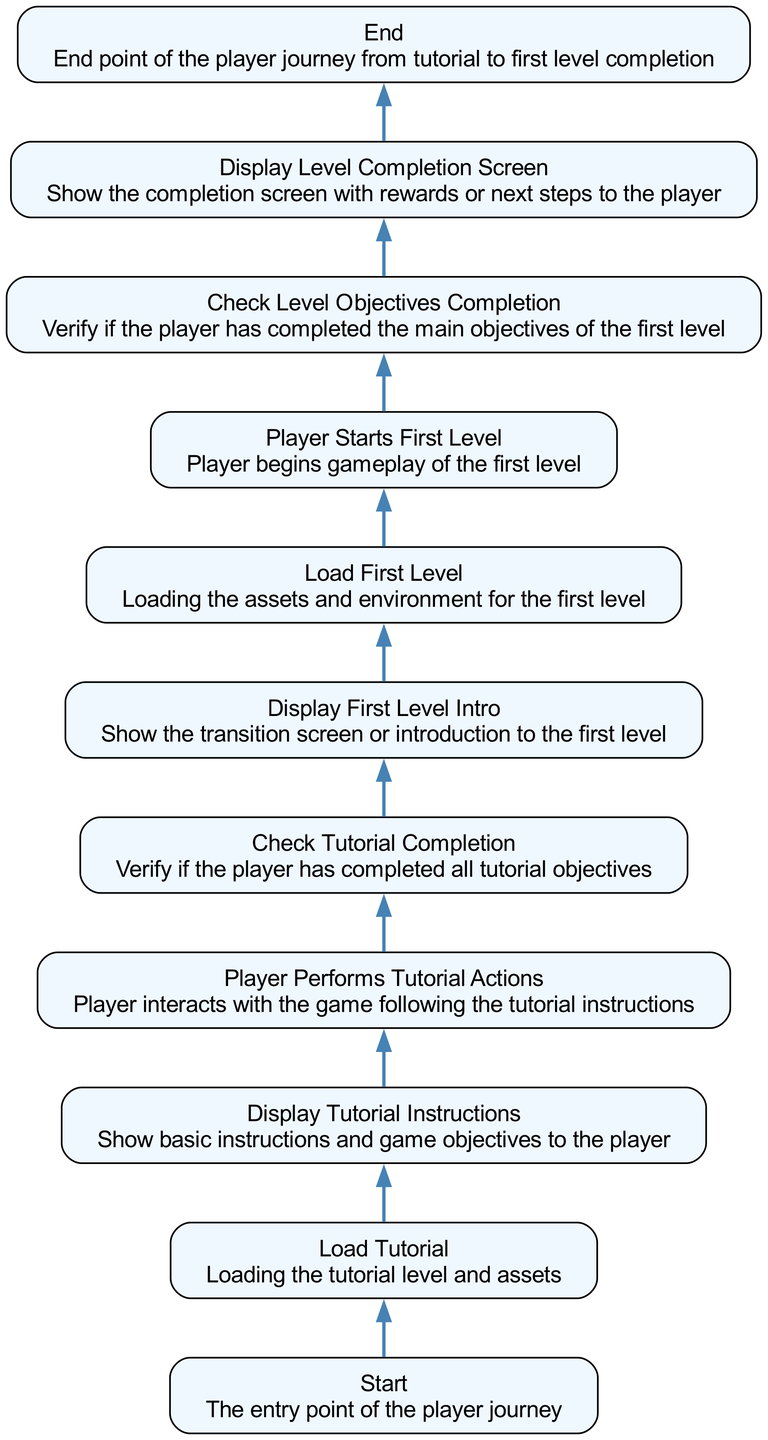What is the first node in the diagram? The first node listed in the flow chart is labeled "Start," marking the entry point where the player journey begins.
Answer: Start How many nodes are present in the diagram? By counting the nodes listed, there are a total of eleven distinct nodes representing various steps in the player journey from tutorial to first level completion.
Answer: Eleven What follows the "Check Tutorial Completion" node? Directly succeeding the "Check Tutorial Completion" node, the next step is the "Display First Level Intro," indicating what comes after checking tutorial progress.
Answer: Display First Level Intro Which node represents the player's initial interaction with the game? The node titled "Player Performs Tutorial Actions" specifically denotes the stage where the player actively engages with the game based on tutorial instructions.
Answer: Player Performs Tutorial Actions Which two nodes are directly connected by an edge? The "Load Tutorial" node connects to the "Display Tutorial Instructions" node, indicating a direct relationship in the sequence of actions that leads players from loading the tutorial to receiving instructions.
Answer: Load Tutorial to Display Tutorial Instructions What is the last step before reaching completion in the flow? The last step leading to the level completion is the "Check Level Objectives Completion," serving as a critical gate before reaching the final completion stage.
Answer: Check Level Objectives Completion What is the overall purpose of the "Display Level Completion Screen" node? The "Display Level Completion Screen" node serves to show the player the results of their efforts in the first level, including rewards and options for next actions.
Answer: Display Level Completion Screen How does the flow from "Load First Level" to "Player Starts First Level" occur? Once the assets and environment are loaded in "Load First Level," the player transitions directly into gameplay, marked by the node "Player Starts First Level," showing a clear progression in the player journey.
Answer: Player Starts First Level What signifies the transition from tutorial to level gameplay? The "Display First Level Intro" node signifies the transition point, serving as an introductory screen that prepares the player to start the first level after completing the tutorial.
Answer: Display First Level Intro 